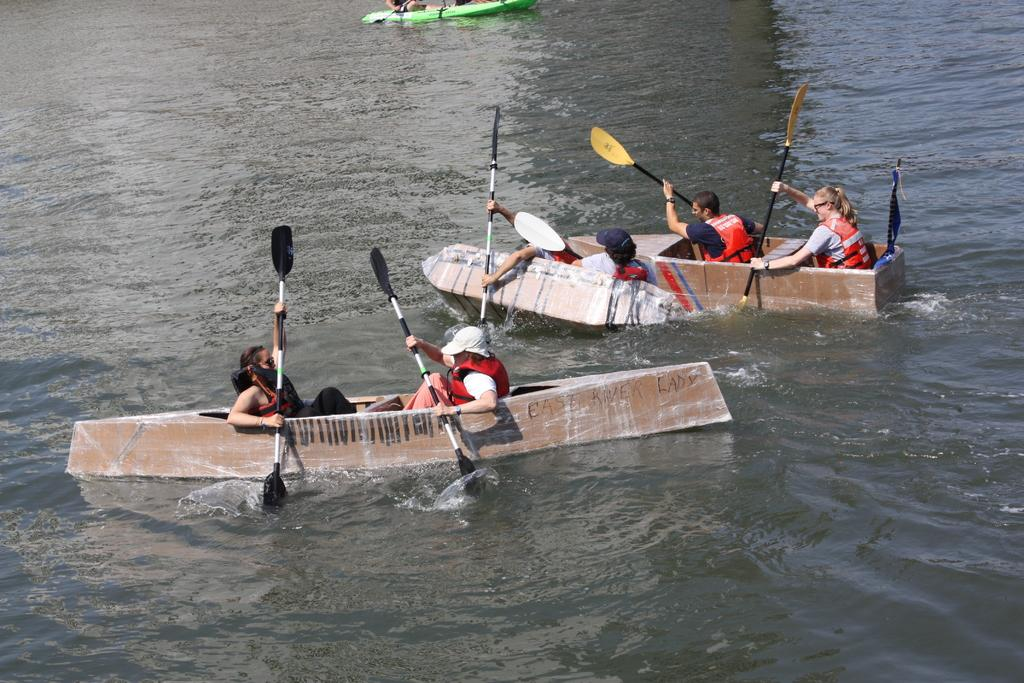How many persons are in the image? There are persons in the image. What are the persons doing in the image? The persons are rowing a boat. Where is the boat located in the image? The boat is in a lake. What type of advertisement can be seen on the boat in the image? There is no advertisement present on the boat in the image. What appliance is being used by the persons to row the boat in the image? The persons are using oars to row the boat, which are not appliances. 